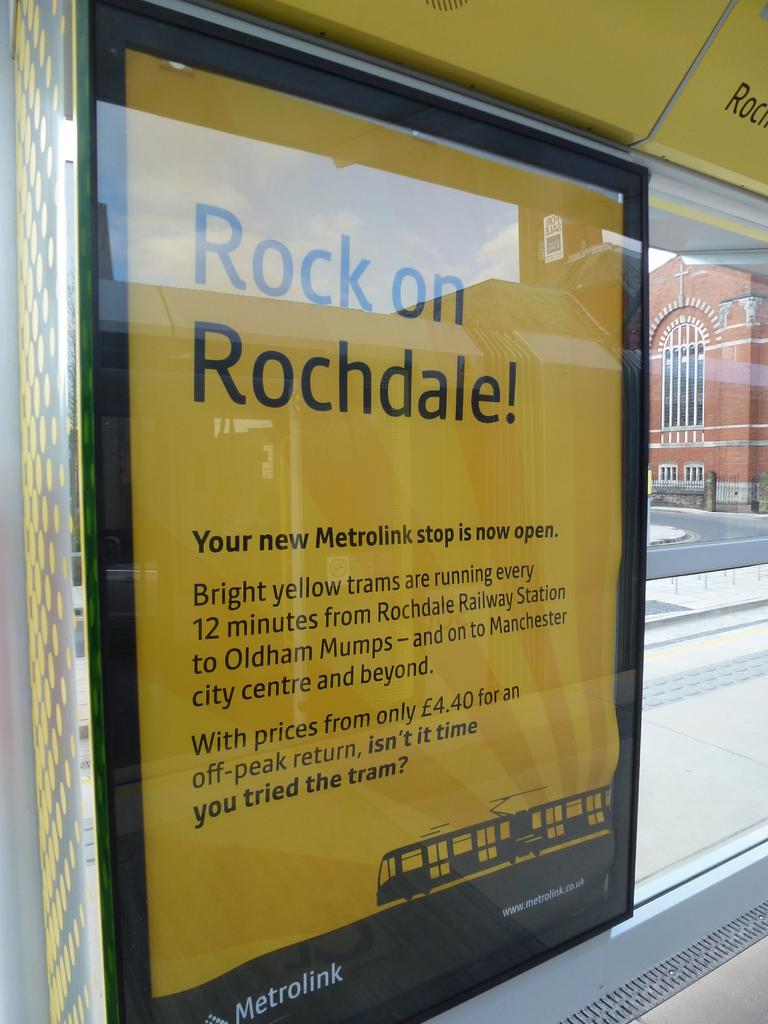<image>
Share a concise interpretation of the image provided. A Metrolink sign saying Rock on Rochdale in yellow. 